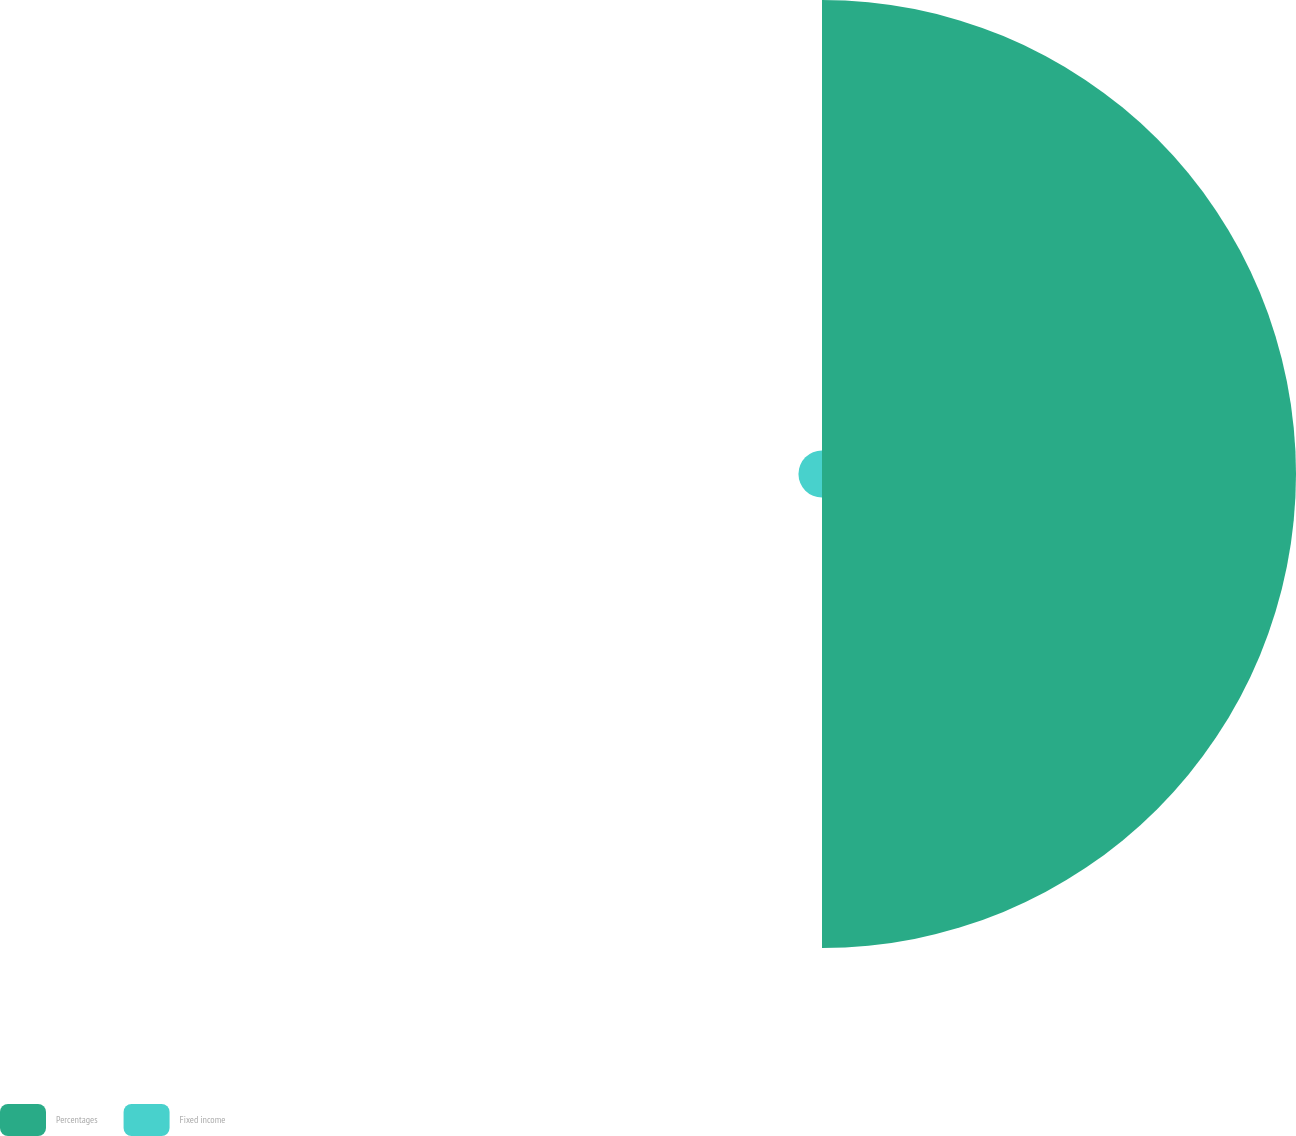<chart> <loc_0><loc_0><loc_500><loc_500><pie_chart><fcel>Percentages<fcel>Fixed income<nl><fcel>95.27%<fcel>4.73%<nl></chart> 